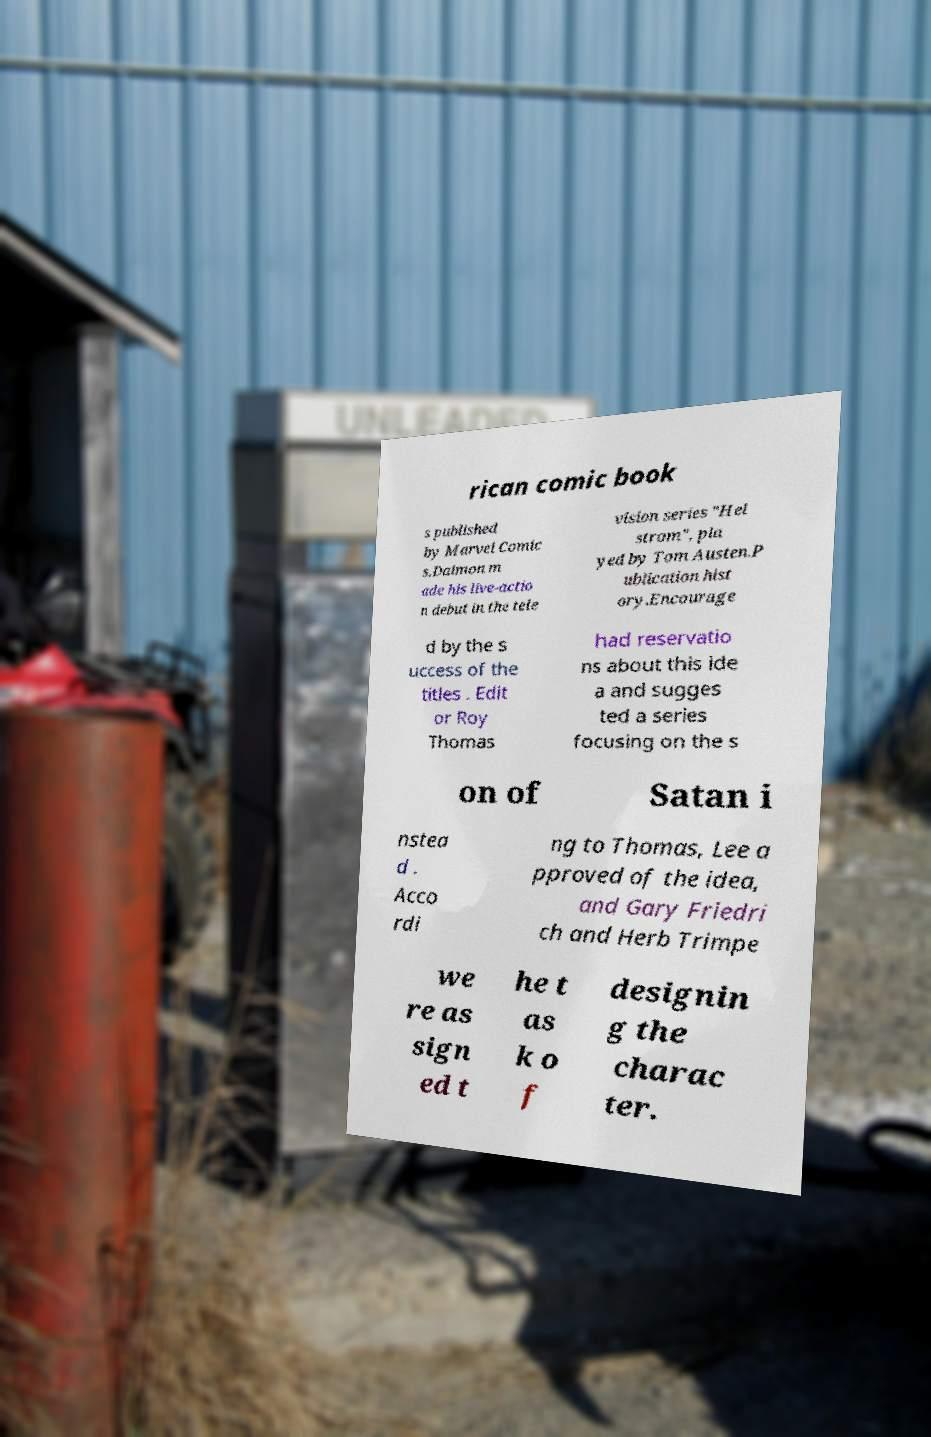Please read and relay the text visible in this image. What does it say? rican comic book s published by Marvel Comic s.Daimon m ade his live-actio n debut in the tele vision series "Hel strom", pla yed by Tom Austen.P ublication hist ory.Encourage d by the s uccess of the titles . Edit or Roy Thomas had reservatio ns about this ide a and sugges ted a series focusing on the s on of Satan i nstea d . Acco rdi ng to Thomas, Lee a pproved of the idea, and Gary Friedri ch and Herb Trimpe we re as sign ed t he t as k o f designin g the charac ter. 